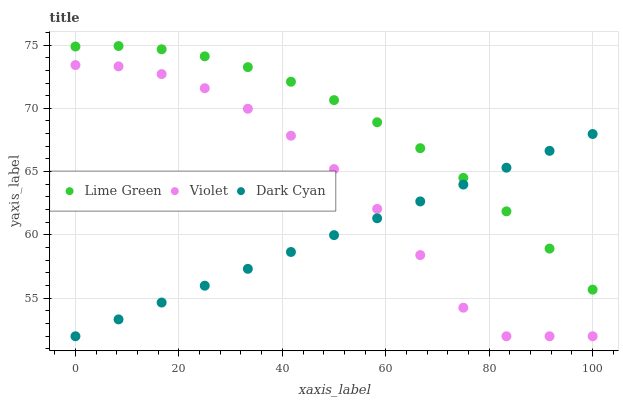Does Dark Cyan have the minimum area under the curve?
Answer yes or no. Yes. Does Lime Green have the maximum area under the curve?
Answer yes or no. Yes. Does Violet have the minimum area under the curve?
Answer yes or no. No. Does Violet have the maximum area under the curve?
Answer yes or no. No. Is Dark Cyan the smoothest?
Answer yes or no. Yes. Is Violet the roughest?
Answer yes or no. Yes. Is Lime Green the smoothest?
Answer yes or no. No. Is Lime Green the roughest?
Answer yes or no. No. Does Dark Cyan have the lowest value?
Answer yes or no. Yes. Does Lime Green have the lowest value?
Answer yes or no. No. Does Lime Green have the highest value?
Answer yes or no. Yes. Does Violet have the highest value?
Answer yes or no. No. Is Violet less than Lime Green?
Answer yes or no. Yes. Is Lime Green greater than Violet?
Answer yes or no. Yes. Does Lime Green intersect Dark Cyan?
Answer yes or no. Yes. Is Lime Green less than Dark Cyan?
Answer yes or no. No. Is Lime Green greater than Dark Cyan?
Answer yes or no. No. Does Violet intersect Lime Green?
Answer yes or no. No. 